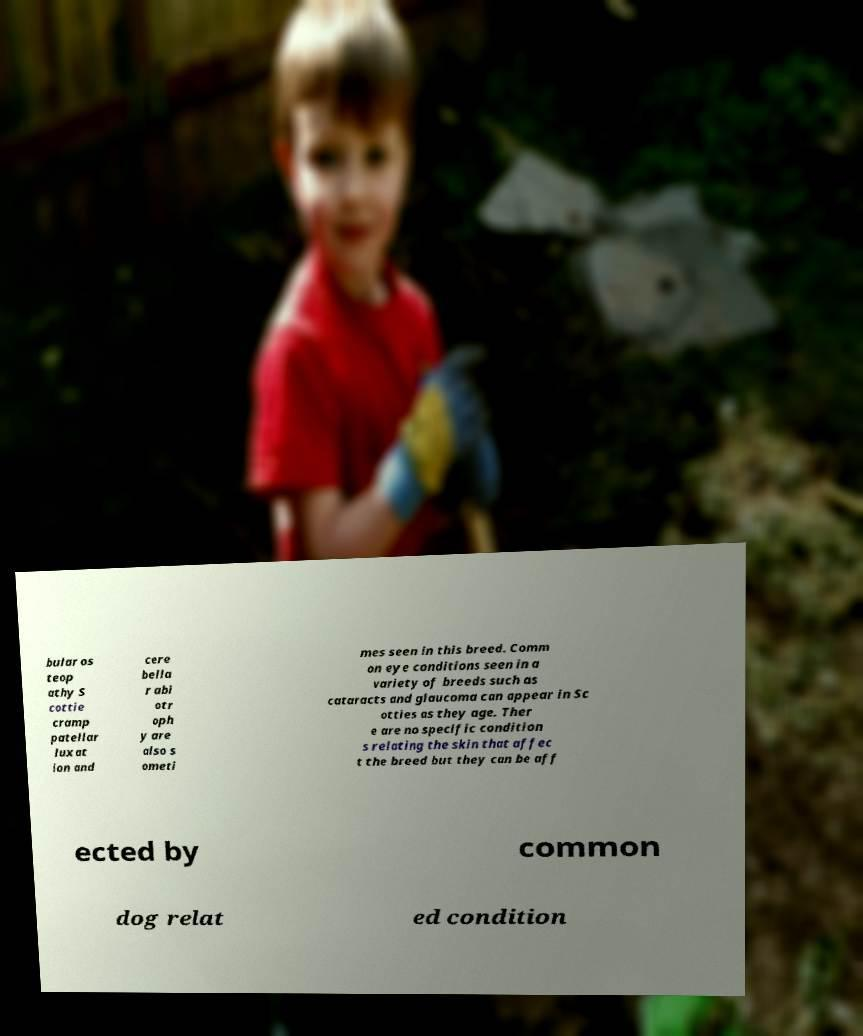Please read and relay the text visible in this image. What does it say? bular os teop athy S cottie cramp patellar luxat ion and cere bella r abi otr oph y are also s ometi mes seen in this breed. Comm on eye conditions seen in a variety of breeds such as cataracts and glaucoma can appear in Sc otties as they age. Ther e are no specific condition s relating the skin that affec t the breed but they can be aff ected by common dog relat ed condition 